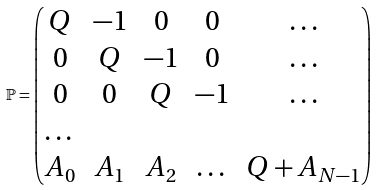Convert formula to latex. <formula><loc_0><loc_0><loc_500><loc_500>\mathbb { P } = \begin{pmatrix} Q & - 1 & 0 & 0 & \dots \\ 0 & Q & - 1 & 0 & \dots \\ 0 & 0 & Q & - 1 & \dots \\ \dots & & & & \\ A _ { 0 } & A _ { 1 } & A _ { 2 } & \dots & Q + A _ { N - 1 } \end{pmatrix}</formula> 